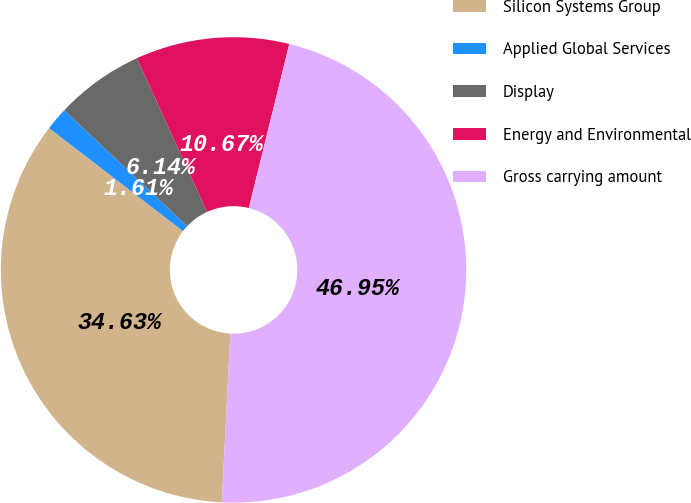Convert chart. <chart><loc_0><loc_0><loc_500><loc_500><pie_chart><fcel>Silicon Systems Group<fcel>Applied Global Services<fcel>Display<fcel>Energy and Environmental<fcel>Gross carrying amount<nl><fcel>34.63%<fcel>1.61%<fcel>6.14%<fcel>10.67%<fcel>46.95%<nl></chart> 